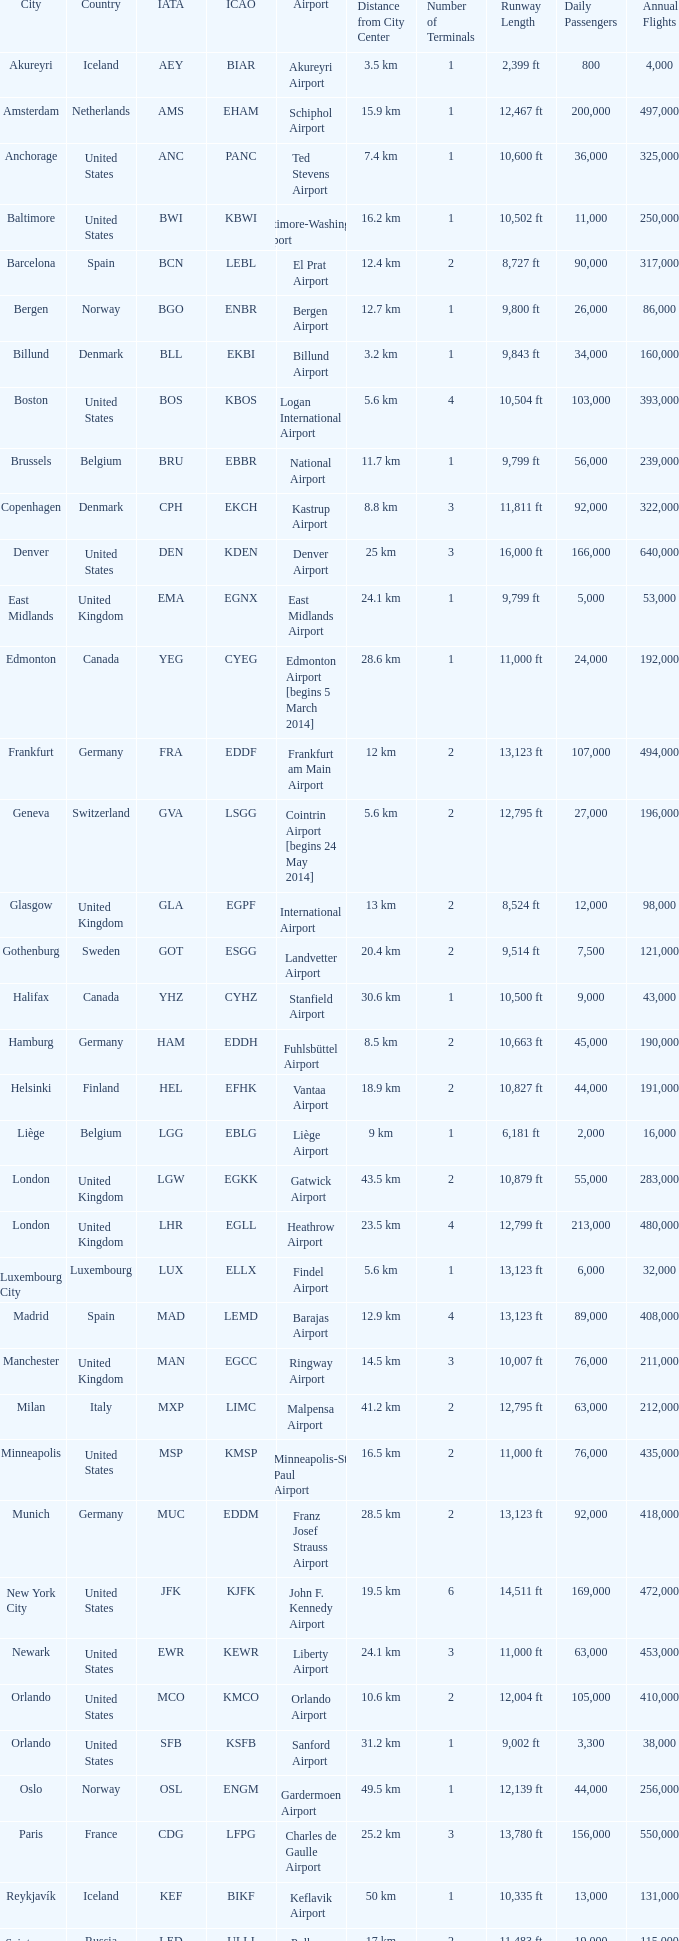What is the Airport with the ICAO fo KSEA? Seattle–Tacoma Airport. 